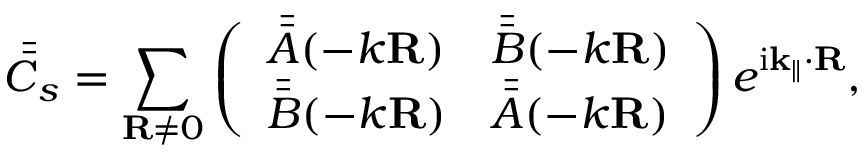Convert formula to latex. <formula><loc_0><loc_0><loc_500><loc_500>\bar { \bar { C } } _ { s } = \sum _ { R \neq 0 } \left ( \begin{array} { l l } { \bar { \bar { A } } ( - k R ) } & { \bar { \bar { B } } ( - k R ) } \\ { \bar { \bar { B } } ( - k R ) } & { \bar { \bar { A } } ( - k R ) } \end{array} \right ) e ^ { i k _ { \| } \cdot R } ,</formula> 